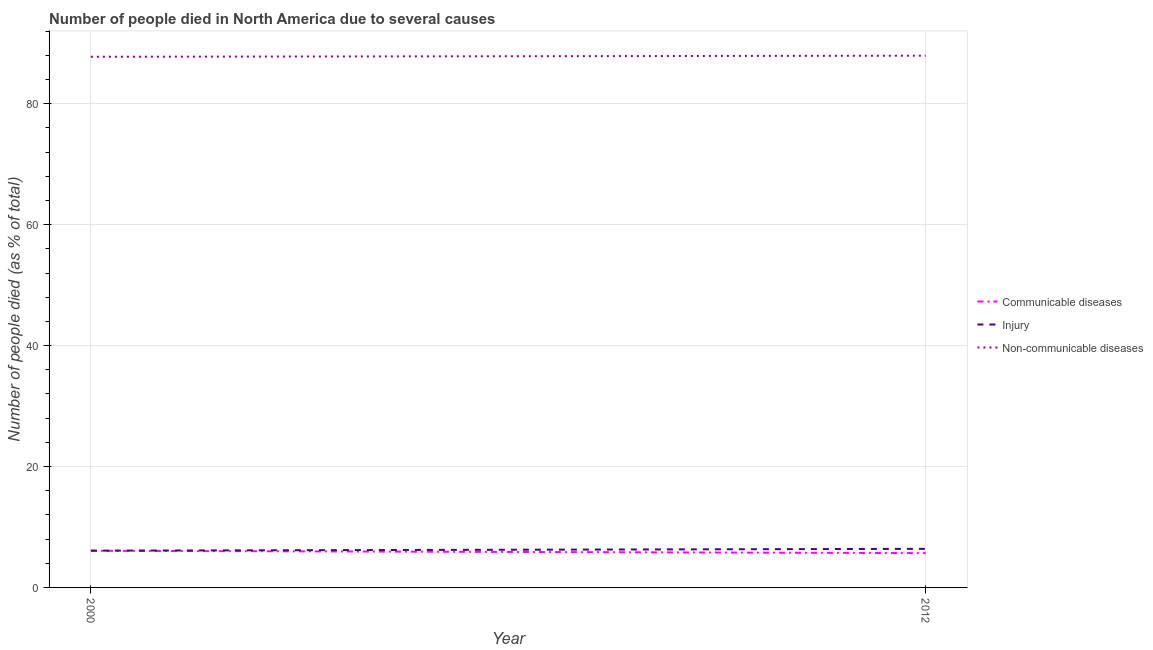How many different coloured lines are there?
Offer a terse response. 3. What is the number of people who died of injury in 2000?
Offer a terse response. 6.08. Across all years, what is the maximum number of people who died of injury?
Give a very brief answer. 6.38. Across all years, what is the minimum number of people who died of injury?
Your answer should be compact. 6.08. In which year was the number of people who died of injury minimum?
Your response must be concise. 2000. What is the total number of people who died of injury in the graph?
Keep it short and to the point. 12.47. What is the difference between the number of people who dies of non-communicable diseases in 2000 and that in 2012?
Provide a short and direct response. -0.18. What is the difference between the number of people who died of communicable diseases in 2012 and the number of people who died of injury in 2000?
Your answer should be compact. -0.41. What is the average number of people who dies of non-communicable diseases per year?
Give a very brief answer. 87.85. In the year 2000, what is the difference between the number of people who died of injury and number of people who died of communicable diseases?
Your answer should be compact. 0.02. What is the ratio of the number of people who dies of non-communicable diseases in 2000 to that in 2012?
Offer a very short reply. 1. In how many years, is the number of people who died of injury greater than the average number of people who died of injury taken over all years?
Ensure brevity in your answer.  1. Is the number of people who dies of non-communicable diseases strictly less than the number of people who died of communicable diseases over the years?
Your response must be concise. No. How many lines are there?
Give a very brief answer. 3. Does the graph contain grids?
Offer a terse response. Yes. What is the title of the graph?
Give a very brief answer. Number of people died in North America due to several causes. Does "Taxes" appear as one of the legend labels in the graph?
Your answer should be very brief. No. What is the label or title of the Y-axis?
Your answer should be compact. Number of people died (as % of total). What is the Number of people died (as % of total) in Communicable diseases in 2000?
Provide a short and direct response. 6.06. What is the Number of people died (as % of total) of Injury in 2000?
Offer a very short reply. 6.08. What is the Number of people died (as % of total) in Non-communicable diseases in 2000?
Provide a succinct answer. 87.76. What is the Number of people died (as % of total) in Communicable diseases in 2012?
Make the answer very short. 5.67. What is the Number of people died (as % of total) in Injury in 2012?
Give a very brief answer. 6.38. What is the Number of people died (as % of total) of Non-communicable diseases in 2012?
Offer a terse response. 87.94. Across all years, what is the maximum Number of people died (as % of total) in Communicable diseases?
Your answer should be very brief. 6.06. Across all years, what is the maximum Number of people died (as % of total) in Injury?
Make the answer very short. 6.38. Across all years, what is the maximum Number of people died (as % of total) of Non-communicable diseases?
Keep it short and to the point. 87.94. Across all years, what is the minimum Number of people died (as % of total) of Communicable diseases?
Provide a short and direct response. 5.67. Across all years, what is the minimum Number of people died (as % of total) of Injury?
Provide a succinct answer. 6.08. Across all years, what is the minimum Number of people died (as % of total) of Non-communicable diseases?
Offer a very short reply. 87.76. What is the total Number of people died (as % of total) of Communicable diseases in the graph?
Give a very brief answer. 11.73. What is the total Number of people died (as % of total) in Injury in the graph?
Offer a terse response. 12.47. What is the total Number of people died (as % of total) in Non-communicable diseases in the graph?
Keep it short and to the point. 175.71. What is the difference between the Number of people died (as % of total) of Communicable diseases in 2000 and that in 2012?
Your answer should be compact. 0.39. What is the difference between the Number of people died (as % of total) of Injury in 2000 and that in 2012?
Provide a succinct answer. -0.3. What is the difference between the Number of people died (as % of total) of Non-communicable diseases in 2000 and that in 2012?
Give a very brief answer. -0.18. What is the difference between the Number of people died (as % of total) in Communicable diseases in 2000 and the Number of people died (as % of total) in Injury in 2012?
Provide a short and direct response. -0.32. What is the difference between the Number of people died (as % of total) of Communicable diseases in 2000 and the Number of people died (as % of total) of Non-communicable diseases in 2012?
Provide a succinct answer. -81.88. What is the difference between the Number of people died (as % of total) in Injury in 2000 and the Number of people died (as % of total) in Non-communicable diseases in 2012?
Give a very brief answer. -81.86. What is the average Number of people died (as % of total) of Communicable diseases per year?
Keep it short and to the point. 5.87. What is the average Number of people died (as % of total) in Injury per year?
Offer a very short reply. 6.23. What is the average Number of people died (as % of total) in Non-communicable diseases per year?
Your answer should be compact. 87.85. In the year 2000, what is the difference between the Number of people died (as % of total) in Communicable diseases and Number of people died (as % of total) in Injury?
Keep it short and to the point. -0.02. In the year 2000, what is the difference between the Number of people died (as % of total) of Communicable diseases and Number of people died (as % of total) of Non-communicable diseases?
Offer a very short reply. -81.7. In the year 2000, what is the difference between the Number of people died (as % of total) in Injury and Number of people died (as % of total) in Non-communicable diseases?
Ensure brevity in your answer.  -81.68. In the year 2012, what is the difference between the Number of people died (as % of total) of Communicable diseases and Number of people died (as % of total) of Injury?
Provide a short and direct response. -0.71. In the year 2012, what is the difference between the Number of people died (as % of total) in Communicable diseases and Number of people died (as % of total) in Non-communicable diseases?
Keep it short and to the point. -82.27. In the year 2012, what is the difference between the Number of people died (as % of total) of Injury and Number of people died (as % of total) of Non-communicable diseases?
Your answer should be very brief. -81.56. What is the ratio of the Number of people died (as % of total) of Communicable diseases in 2000 to that in 2012?
Offer a very short reply. 1.07. What is the ratio of the Number of people died (as % of total) of Injury in 2000 to that in 2012?
Keep it short and to the point. 0.95. What is the difference between the highest and the second highest Number of people died (as % of total) of Communicable diseases?
Ensure brevity in your answer.  0.39. What is the difference between the highest and the second highest Number of people died (as % of total) in Injury?
Provide a short and direct response. 0.3. What is the difference between the highest and the second highest Number of people died (as % of total) of Non-communicable diseases?
Keep it short and to the point. 0.18. What is the difference between the highest and the lowest Number of people died (as % of total) in Communicable diseases?
Give a very brief answer. 0.39. What is the difference between the highest and the lowest Number of people died (as % of total) of Injury?
Your answer should be compact. 0.3. What is the difference between the highest and the lowest Number of people died (as % of total) of Non-communicable diseases?
Your answer should be very brief. 0.18. 